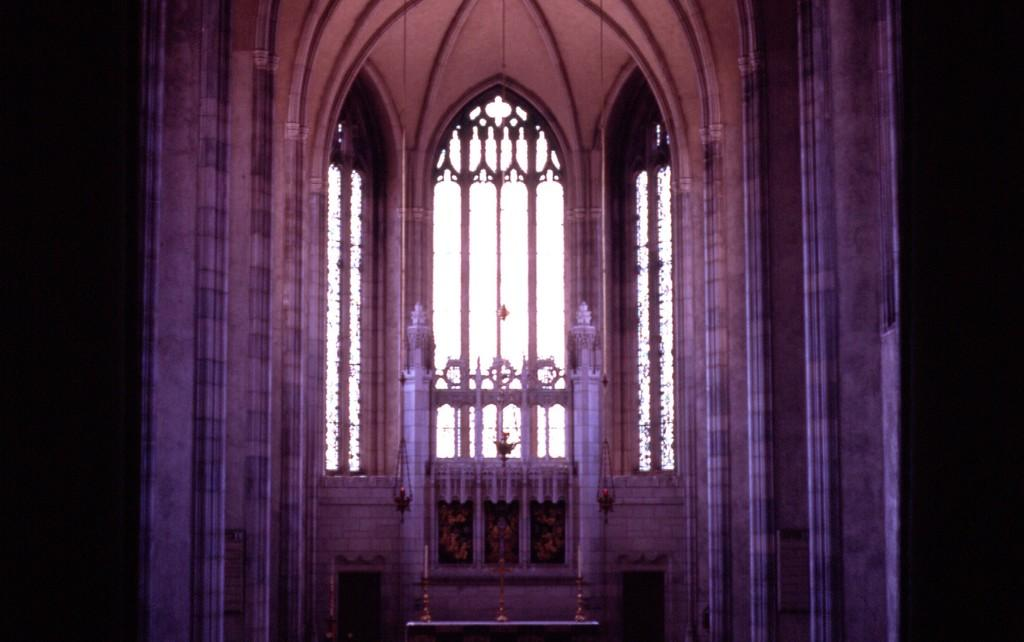What type of location is depicted in the image? The image shows an inner view of a building. What can be seen inside the building? There are candles and decorative objects visible inside the building. How is the lighting in the image? The sides of the image appear dark. Can you tell me how many tigers are present inside the building in the image? There are no tigers present inside the building in the image. What is the fifth object on the left side of the image? The facts provided do not mention a fifth object on the left side of the image. 